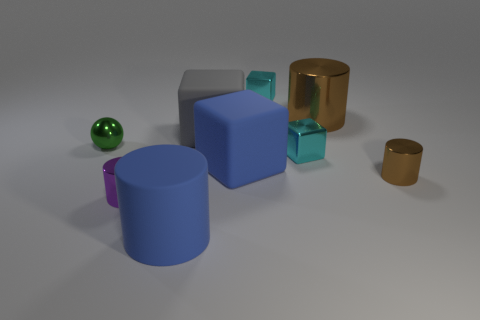Subtract 1 blocks. How many blocks are left? 3 Subtract all cylinders. How many objects are left? 5 Add 8 matte cylinders. How many matte cylinders are left? 9 Add 1 gray matte cubes. How many gray matte cubes exist? 2 Subtract 0 yellow cylinders. How many objects are left? 9 Subtract all large gray metal objects. Subtract all purple things. How many objects are left? 8 